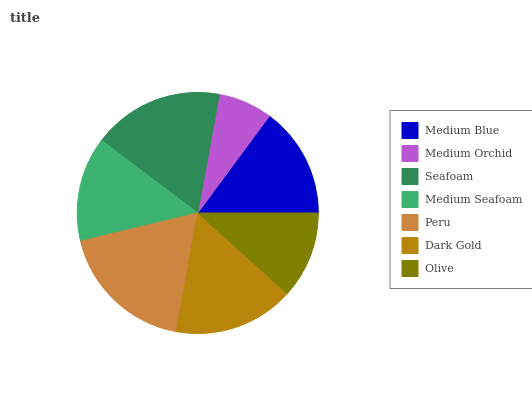Is Medium Orchid the minimum?
Answer yes or no. Yes. Is Peru the maximum?
Answer yes or no. Yes. Is Seafoam the minimum?
Answer yes or no. No. Is Seafoam the maximum?
Answer yes or no. No. Is Seafoam greater than Medium Orchid?
Answer yes or no. Yes. Is Medium Orchid less than Seafoam?
Answer yes or no. Yes. Is Medium Orchid greater than Seafoam?
Answer yes or no. No. Is Seafoam less than Medium Orchid?
Answer yes or no. No. Is Medium Blue the high median?
Answer yes or no. Yes. Is Medium Blue the low median?
Answer yes or no. Yes. Is Dark Gold the high median?
Answer yes or no. No. Is Dark Gold the low median?
Answer yes or no. No. 